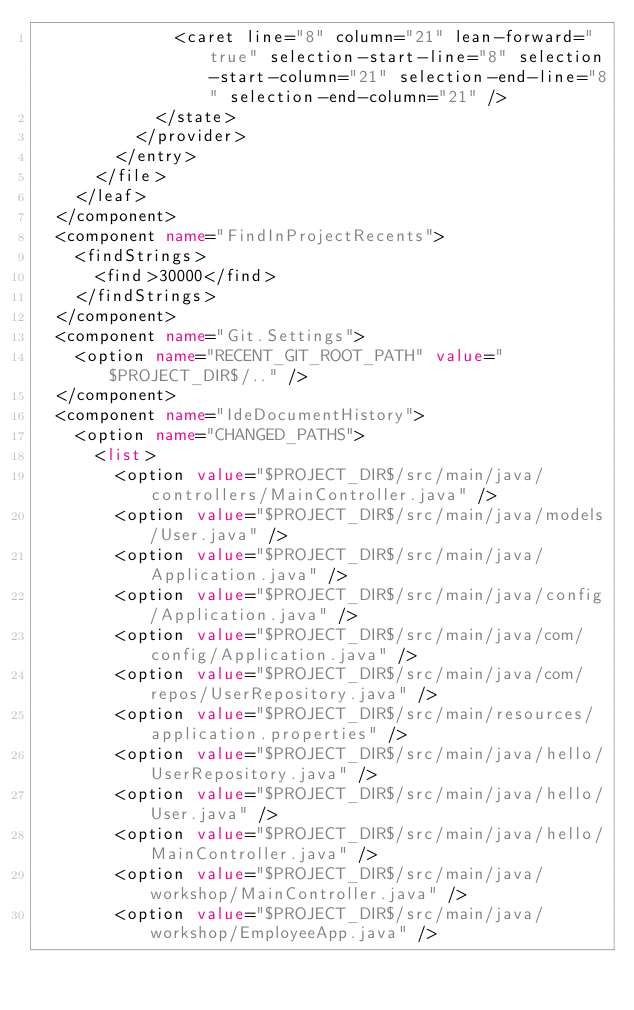<code> <loc_0><loc_0><loc_500><loc_500><_XML_>              <caret line="8" column="21" lean-forward="true" selection-start-line="8" selection-start-column="21" selection-end-line="8" selection-end-column="21" />
            </state>
          </provider>
        </entry>
      </file>
    </leaf>
  </component>
  <component name="FindInProjectRecents">
    <findStrings>
      <find>30000</find>
    </findStrings>
  </component>
  <component name="Git.Settings">
    <option name="RECENT_GIT_ROOT_PATH" value="$PROJECT_DIR$/.." />
  </component>
  <component name="IdeDocumentHistory">
    <option name="CHANGED_PATHS">
      <list>
        <option value="$PROJECT_DIR$/src/main/java/controllers/MainController.java" />
        <option value="$PROJECT_DIR$/src/main/java/models/User.java" />
        <option value="$PROJECT_DIR$/src/main/java/Application.java" />
        <option value="$PROJECT_DIR$/src/main/java/config/Application.java" />
        <option value="$PROJECT_DIR$/src/main/java/com/config/Application.java" />
        <option value="$PROJECT_DIR$/src/main/java/com/repos/UserRepository.java" />
        <option value="$PROJECT_DIR$/src/main/resources/application.properties" />
        <option value="$PROJECT_DIR$/src/main/java/hello/UserRepository.java" />
        <option value="$PROJECT_DIR$/src/main/java/hello/User.java" />
        <option value="$PROJECT_DIR$/src/main/java/hello/MainController.java" />
        <option value="$PROJECT_DIR$/src/main/java/workshop/MainController.java" />
        <option value="$PROJECT_DIR$/src/main/java/workshop/EmployeeApp.java" /></code> 